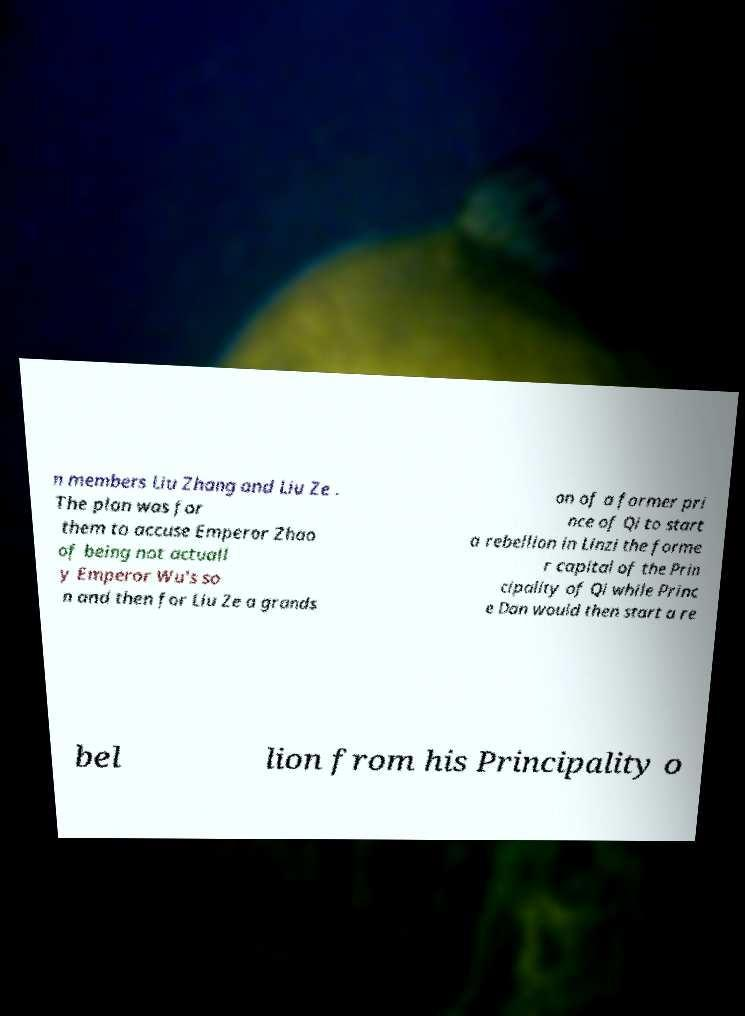Can you read and provide the text displayed in the image?This photo seems to have some interesting text. Can you extract and type it out for me? n members Liu Zhang and Liu Ze . The plan was for them to accuse Emperor Zhao of being not actuall y Emperor Wu's so n and then for Liu Ze a grands on of a former pri nce of Qi to start a rebellion in Linzi the forme r capital of the Prin cipality of Qi while Princ e Dan would then start a re bel lion from his Principality o 